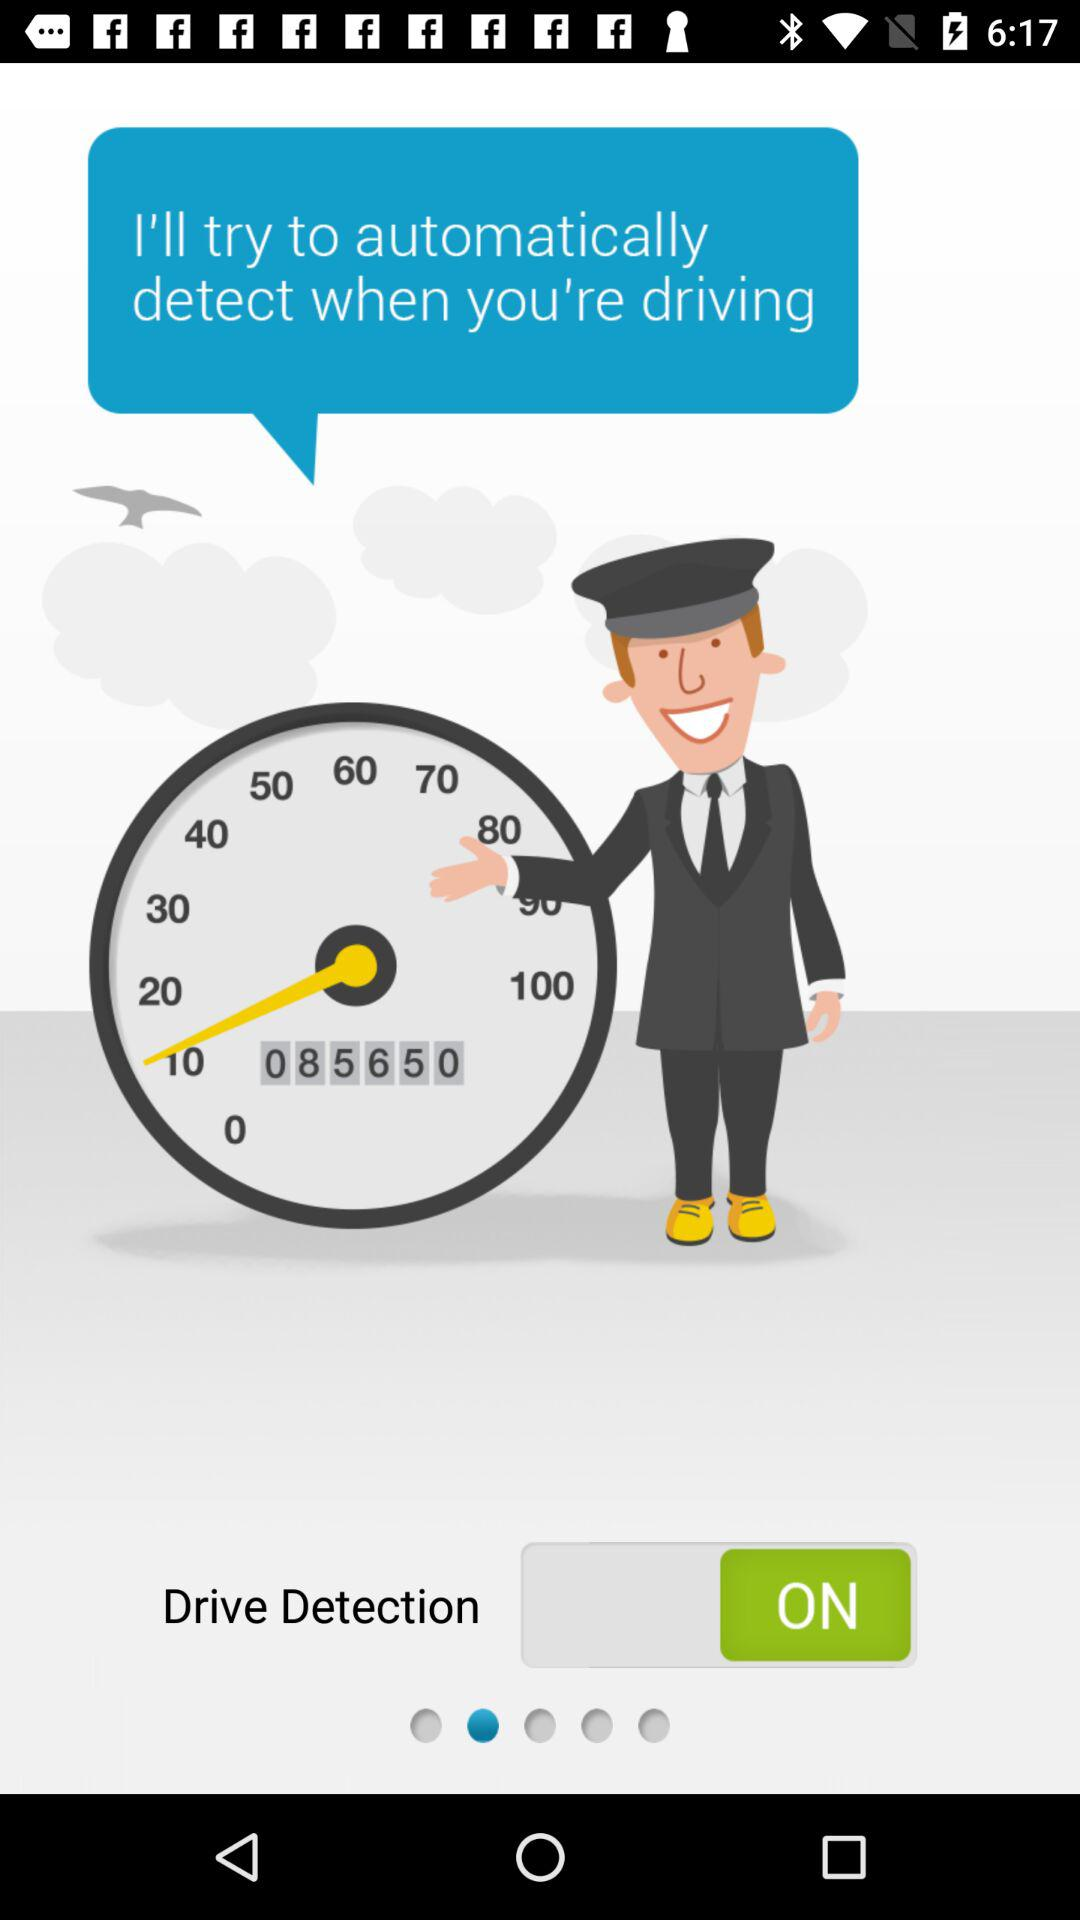What's the status for "Drive Detection"? The status is "on". 